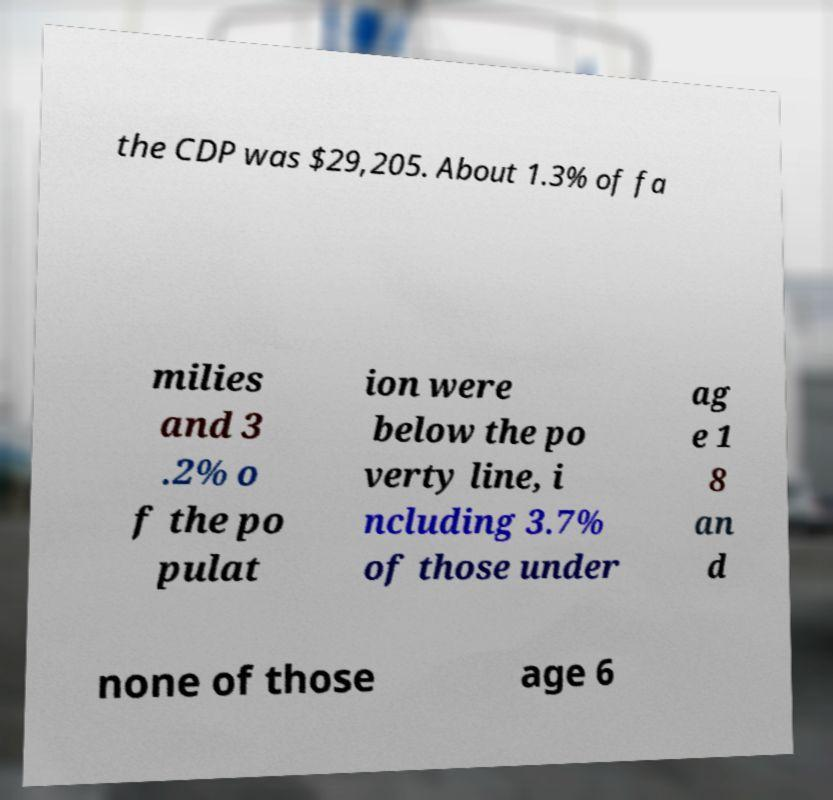Please identify and transcribe the text found in this image. the CDP was $29,205. About 1.3% of fa milies and 3 .2% o f the po pulat ion were below the po verty line, i ncluding 3.7% of those under ag e 1 8 an d none of those age 6 